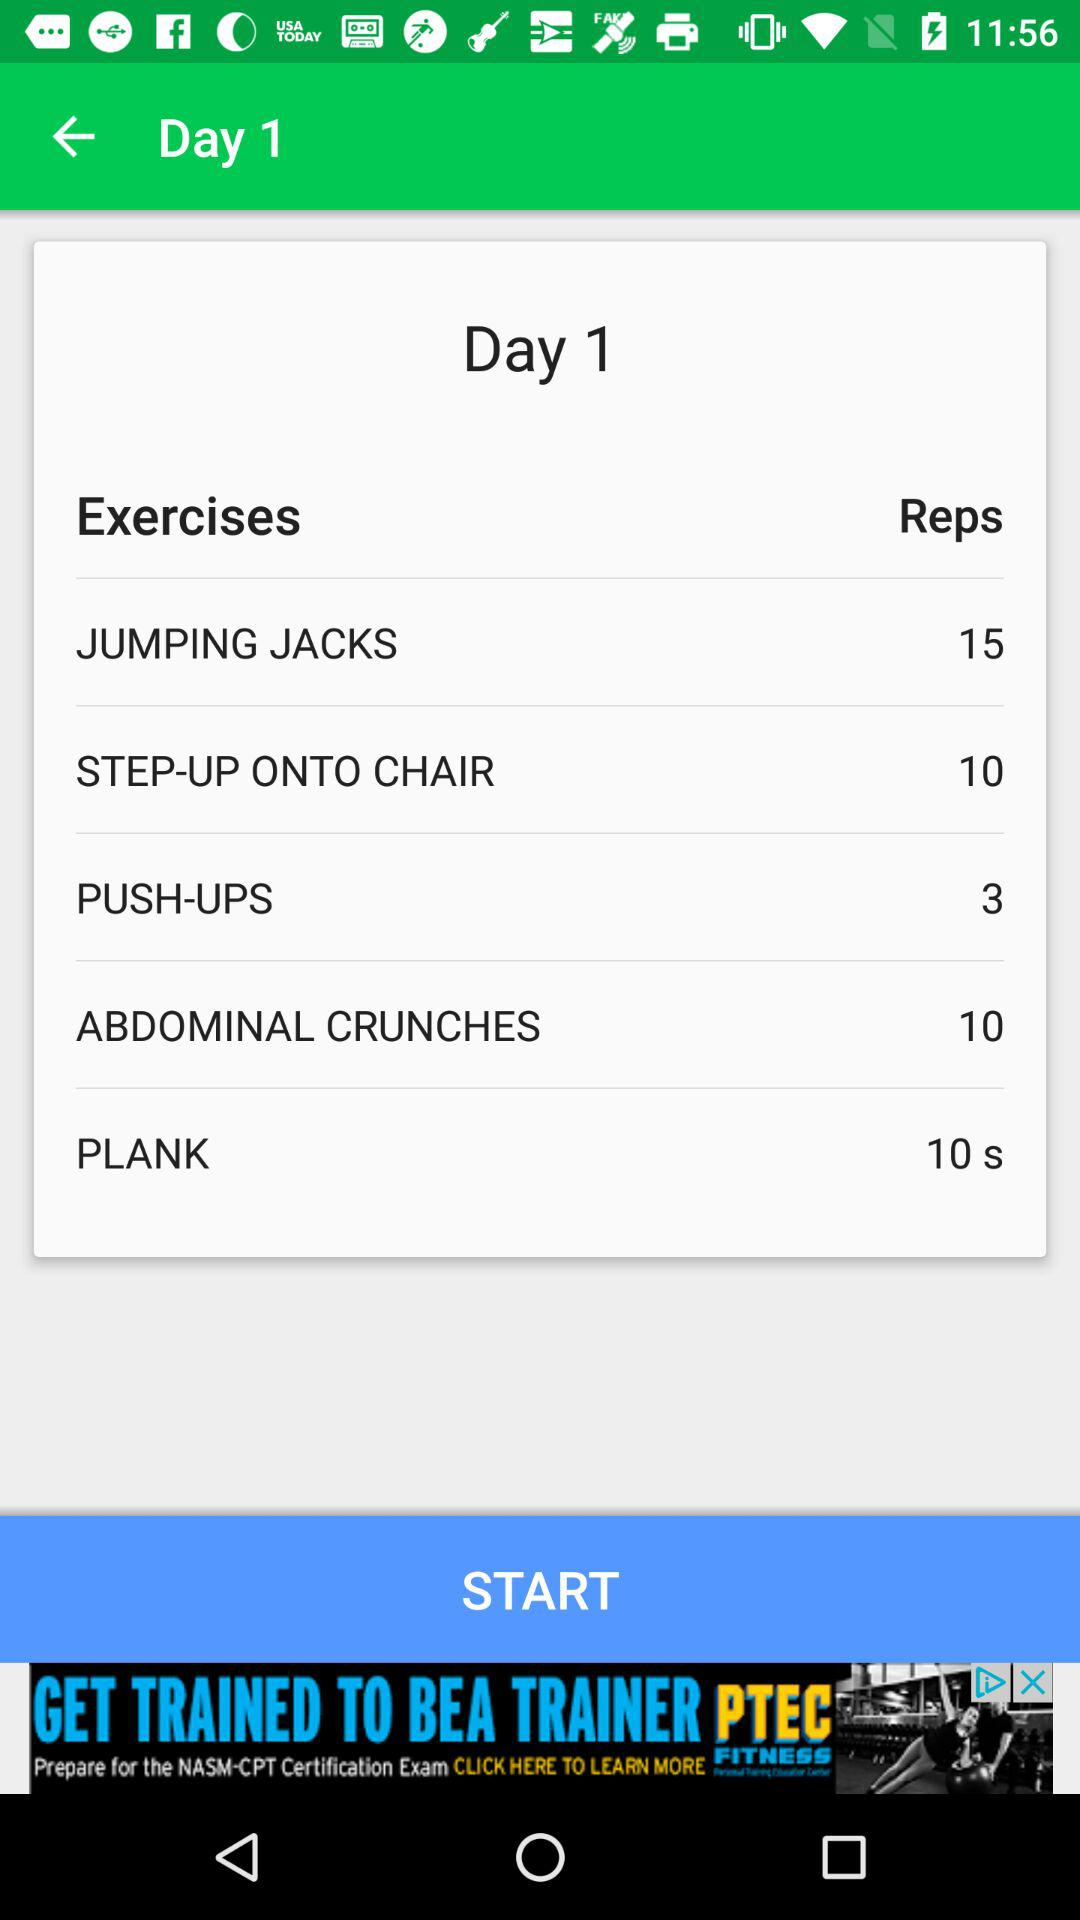What is the number of reps for push-ups? The number of reps for push-ups is 3. 